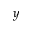Convert formula to latex. <formula><loc_0><loc_0><loc_500><loc_500>y</formula> 